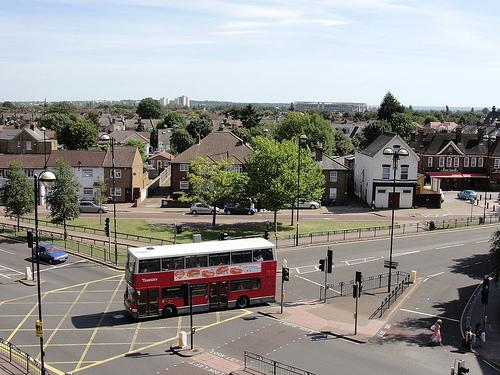What is the activity of the people walking on the sidewalk and the color of one person's attire? People are walking on the sidewalk and one person is wearing a pink outfit. Describe the appearance of the houses in the background and mention the color of one specific house. There is a row of houses in the background with a two-story white house among them. Identify the primary object in the image and provide a brief description of its activity. A red and white double-decker bus is driving through an intersection. Mention the predominant color and shape of the area between the roads. The predominant color is green and the shape of the area is a triangular patch of grass. Identify two types of parked vehicles and their location in the image. There are two parked cars on the street and a car in a parking lot. Mention the color of the traffic lights in the center of the intersection and describe their surroundings. The traffic lights are located at the center of the intersection surrounded by crossed yellow lines marking the area. What color is the car waiting to cross the intersection and what action is it performing? The blue car is waiting at a red light to cross the intersection. State what can be seen in the skyline of the image, mainly consisting of natural and man-made objects. The skyline features trees, buildings, and houses. Count the number of people crossing the street and mention the color of the outfit of one of them. There are 3 people crossing the street, and one of them is wearing pink. Are there any anomalies in this image? No Which objects are in interaction in the image near the intersection? double decker bus, blue car, traffic light Rate the image quality on a scale of 1 to 10 with 10 being the highest. 7 Identify the colors of the double decker bus in the image. red and white Notice the nail salon with a purple storefront on the left side of the street. There is no mention of a nail salon or a purple storefront in the given image information, so including it as an instruction would be misleading. Determine the number of cars parked on the street in the image. two What are the activities involving the humans in the image? people walking, woman crossing the street, people crossing the street on foot Determine whether the objects in the picture are in motion or at rest. double decker bus: driving, blue car: waiting, people crossing: walking, parked cars: at rest How many traffic lights are there in this picture? three What is the buildings in this image consist of? houses, white two-story house, skyscrapers Enumerate the objects in front of the white two-story house. red awning, street sign, cars parked on the street Just behind the metal fence, you can see a group of children playing soccer. Though the given image information mentions a metal fence, there is no mention of children or soccer. This instruction would mislead the viewer into believing that a group of children is present in the background. What types of vehicles are located in the image? double decker bus, blue car List the objects that have colors blue and green as their main colors. blue car, green grass, green trees Admire the magnificent mural painted on the side of the red and white bus. The given image information describes a red and white double-decker bus, but there is no mention of any mural painted on it. This instruction would mislead the viewer into believing there is additional artwork on the bus. Provide examples of at least three objects found within the image. double decker bus, traffic light, metal fence Explain the scene of the captured image. The image shows a red and white double decker bus driving through an intersection, a blue car waiting, several houses in the background, people crossing the street, and trees. Are there any green objects in the image? If yes, what are they? Yes, the green objects are grass and trees. Can you spot the huge billboard advertising a new movie near the intersection? There is no mention of a billboard in the given image information, especially not one advertising a movie. This instruction would lead the viewer to search for something that is not present in the image. How did you like the yellow fire hydrant next to the woman crossing the street? A fire hydrant is not mentioned in the given image information, so asking about it would lead the viewer to search for a non-existent object in the image. Look! A luxurious red convertible is parked next to the blue car waiting at the red light. While there is mention of a blue car waiting at a red light, there is no mention of a luxurious red convertible in the given image information. This instruction would mislead the viewer into seeking a non-existent object in the image. 